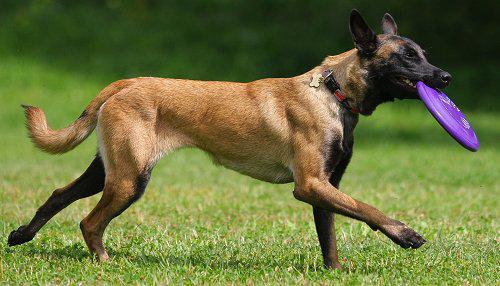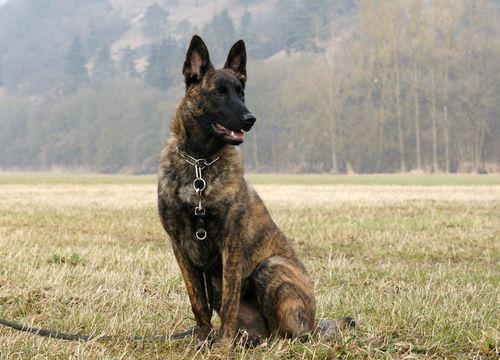The first image is the image on the left, the second image is the image on the right. Analyze the images presented: Is the assertion "An image shows a dog sitting upright in grass, wearing a leash." valid? Answer yes or no. Yes. 